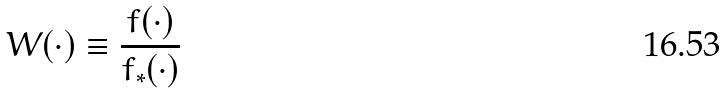Convert formula to latex. <formula><loc_0><loc_0><loc_500><loc_500>W ( \cdot ) \equiv \frac { f ( \cdot ) } { f _ { * } ( \cdot ) }</formula> 